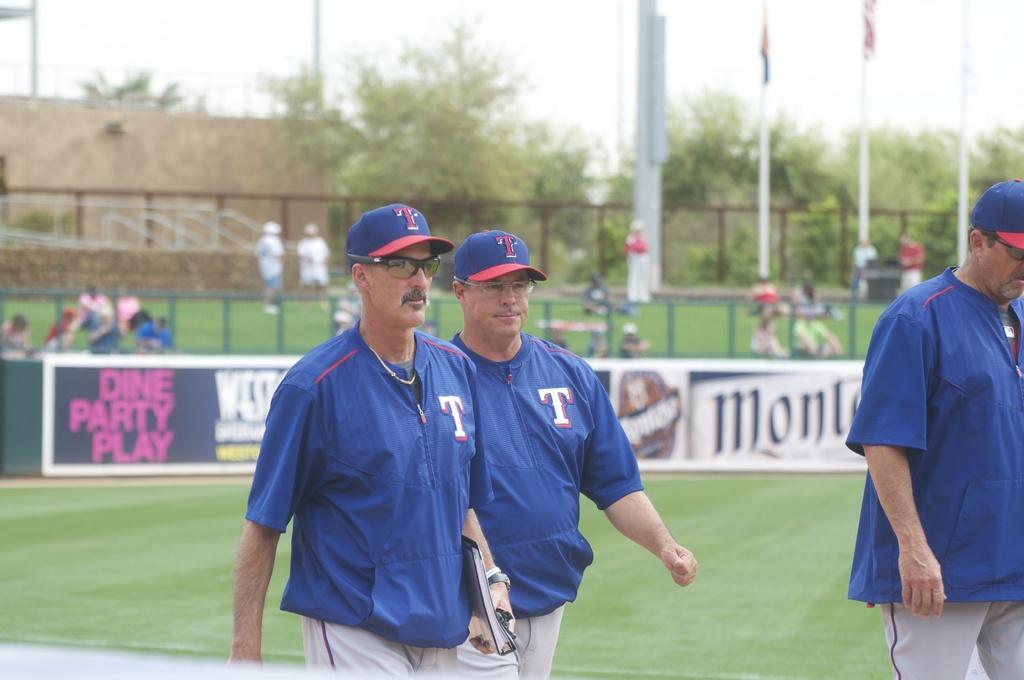How would you summarize this image in a sentence or two? In this picture there is a man who is wearing cap, spectacle, t-shirt, watch, band and trouser. He is holding a book. Beside him there is another man who is walking. On the right there is another man who is standing on the ground. In the background we can see many peoples were sitting and standing on the grass. beside them i can see the posters and banners on the fencing. In the right background i can see some poles and flags which is near to the fencing. In the left background i can see the buildings. Beside that i can see many trees and plants. At the top there is a sky. 